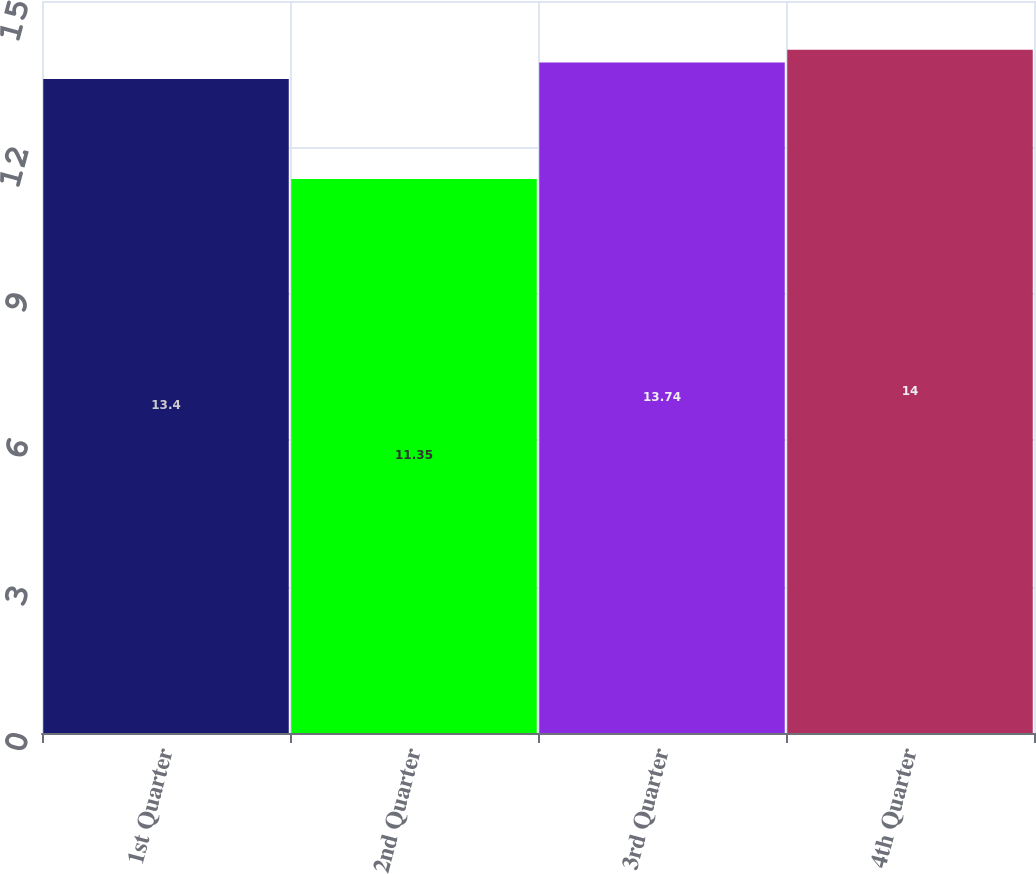Convert chart. <chart><loc_0><loc_0><loc_500><loc_500><bar_chart><fcel>1st Quarter<fcel>2nd Quarter<fcel>3rd Quarter<fcel>4th Quarter<nl><fcel>13.4<fcel>11.35<fcel>13.74<fcel>14<nl></chart> 